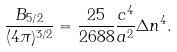Convert formula to latex. <formula><loc_0><loc_0><loc_500><loc_500>\frac { B _ { 5 / 2 } } { ( 4 \pi ) ^ { 3 / 2 } } = \frac { 2 5 } { 2 6 8 8 } \frac { c ^ { 4 } } { a ^ { 2 } } \Delta n ^ { 4 } .</formula> 